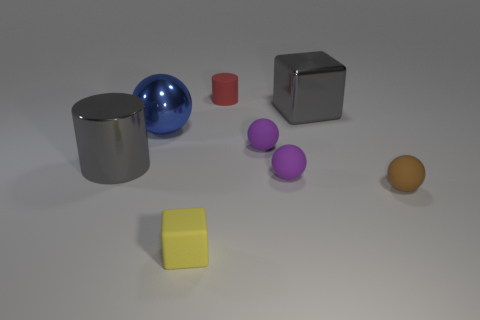What color is the metallic thing that is behind the large gray cylinder and to the left of the yellow object? blue 